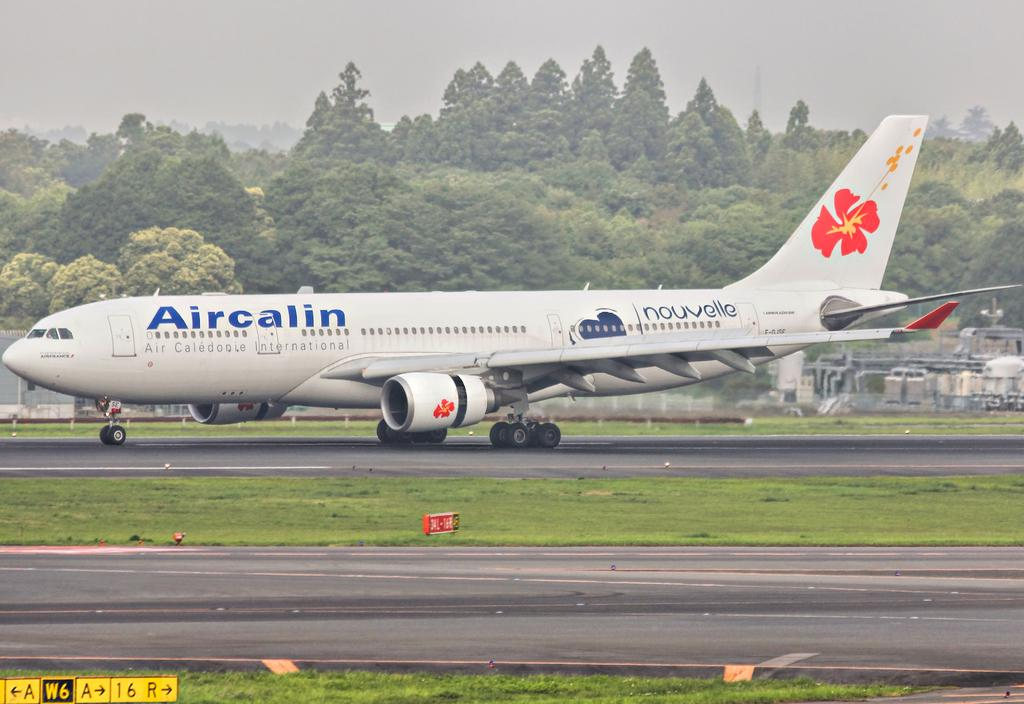<image>
Relay a brief, clear account of the picture shown. an Aircalin plane just after landing on a runway 